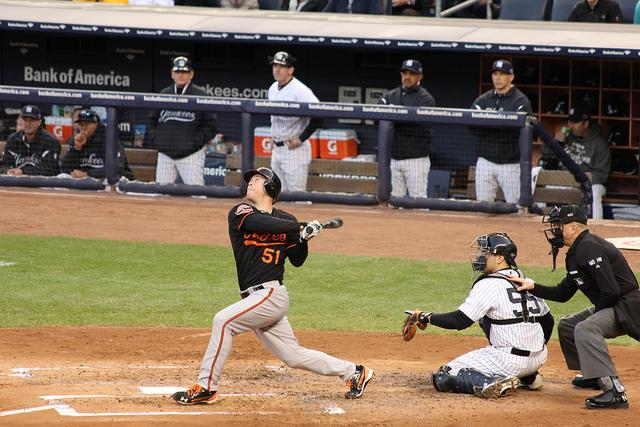What holds the beverages for the players in the dugout?

Choices:
A) coolers
B) shelves
C) umpire
D) fans coolers 